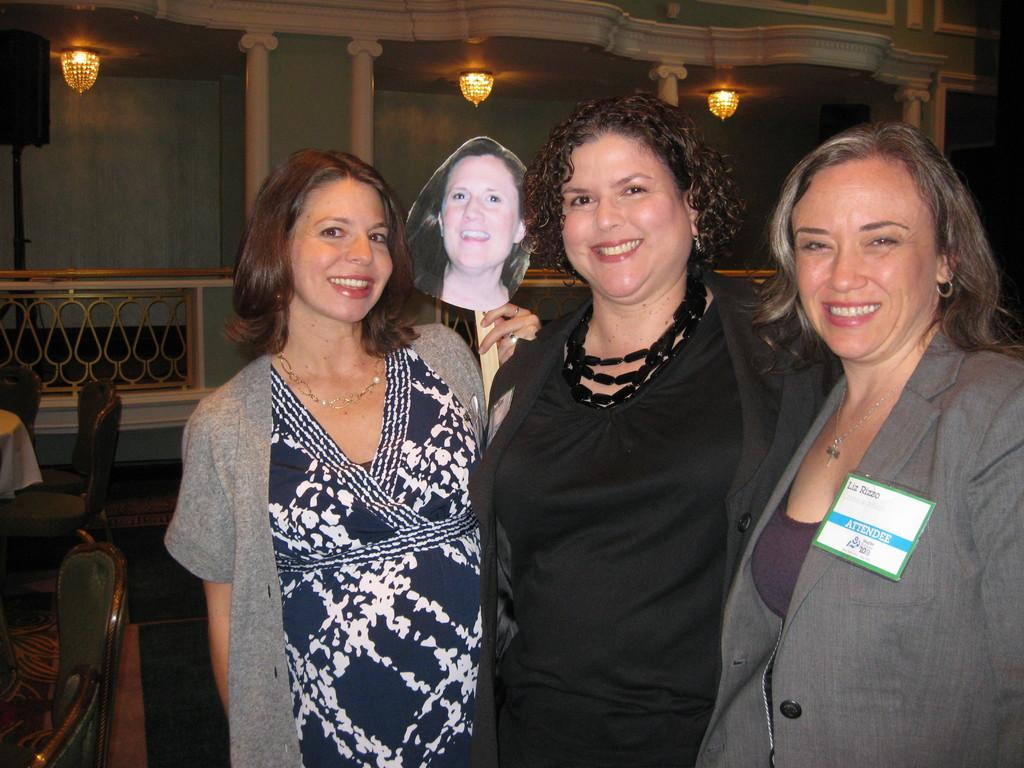How many women are in the image? There are three women in the image. What expression do the women have in the image? The women are smiling in the image. What type of furniture is present in the image? There are chairs in the image. What can be seen on the ceiling in the background of the image? There are lamps on the ceiling in the background of the image. What type of breakfast is being prepared by the women in the image? There is no indication of breakfast or any food preparation in the image. Can you tell me how many pears are on the table in the image? There are no pears present in the image. 